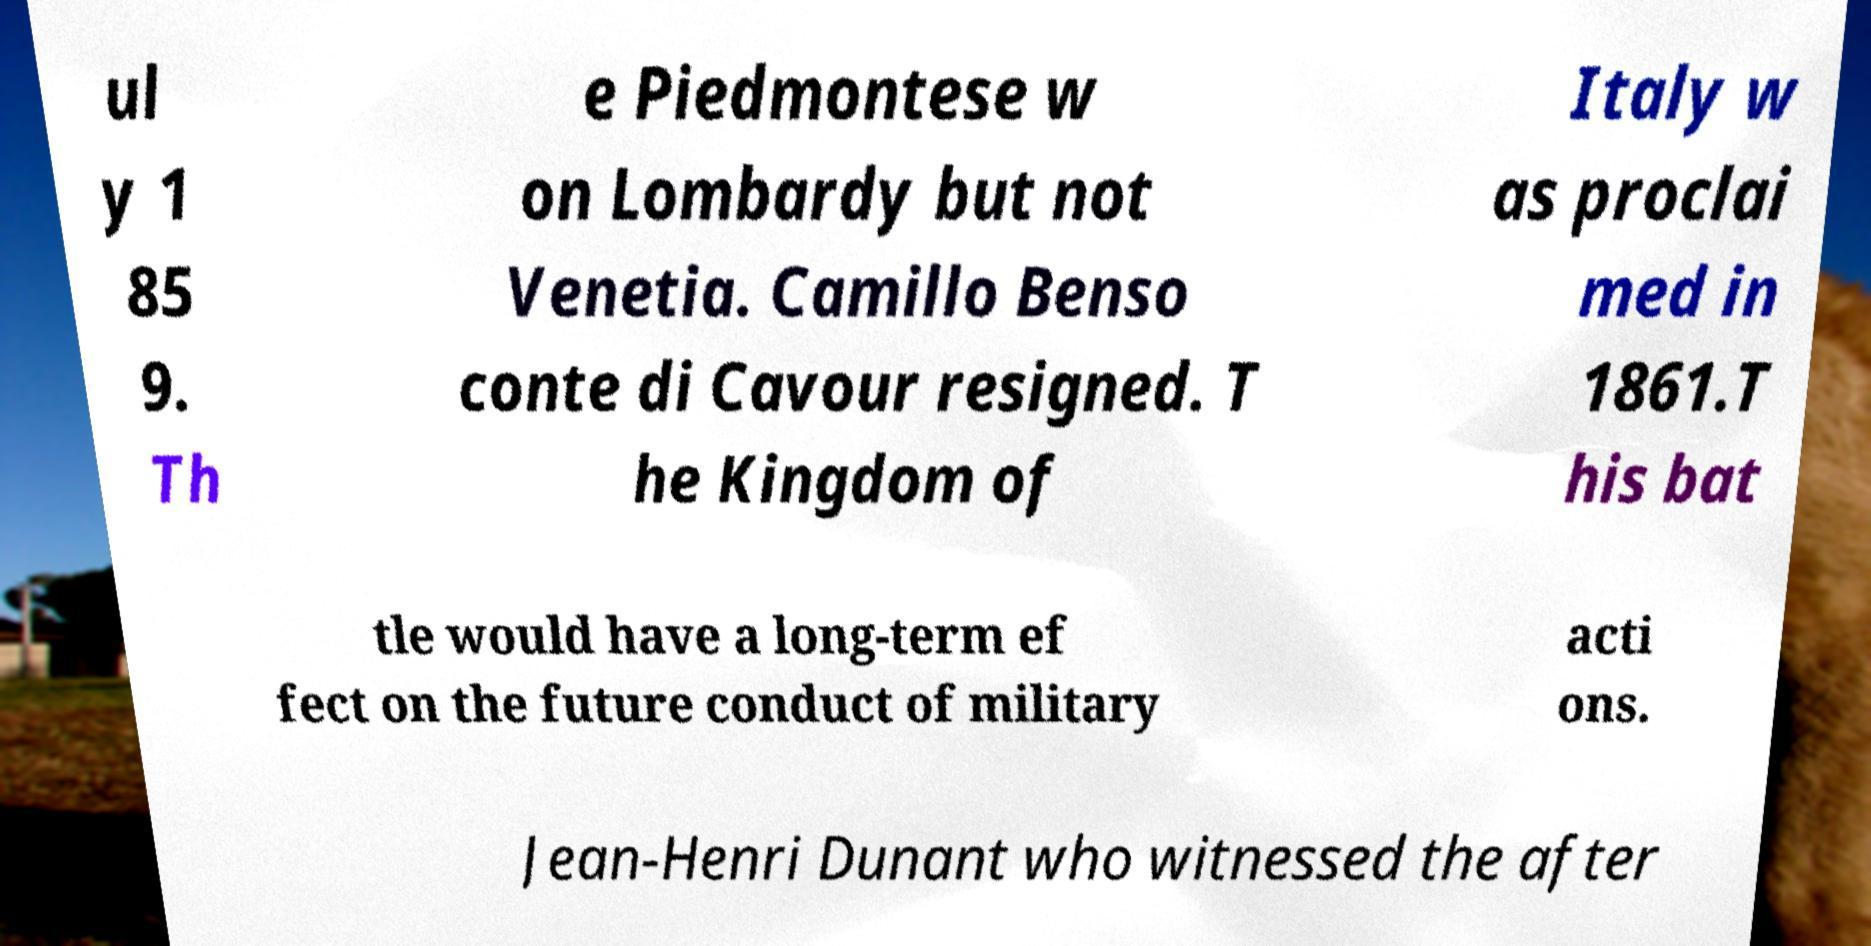Can you read and provide the text displayed in the image?This photo seems to have some interesting text. Can you extract and type it out for me? ul y 1 85 9. Th e Piedmontese w on Lombardy but not Venetia. Camillo Benso conte di Cavour resigned. T he Kingdom of Italy w as proclai med in 1861.T his bat tle would have a long-term ef fect on the future conduct of military acti ons. Jean-Henri Dunant who witnessed the after 